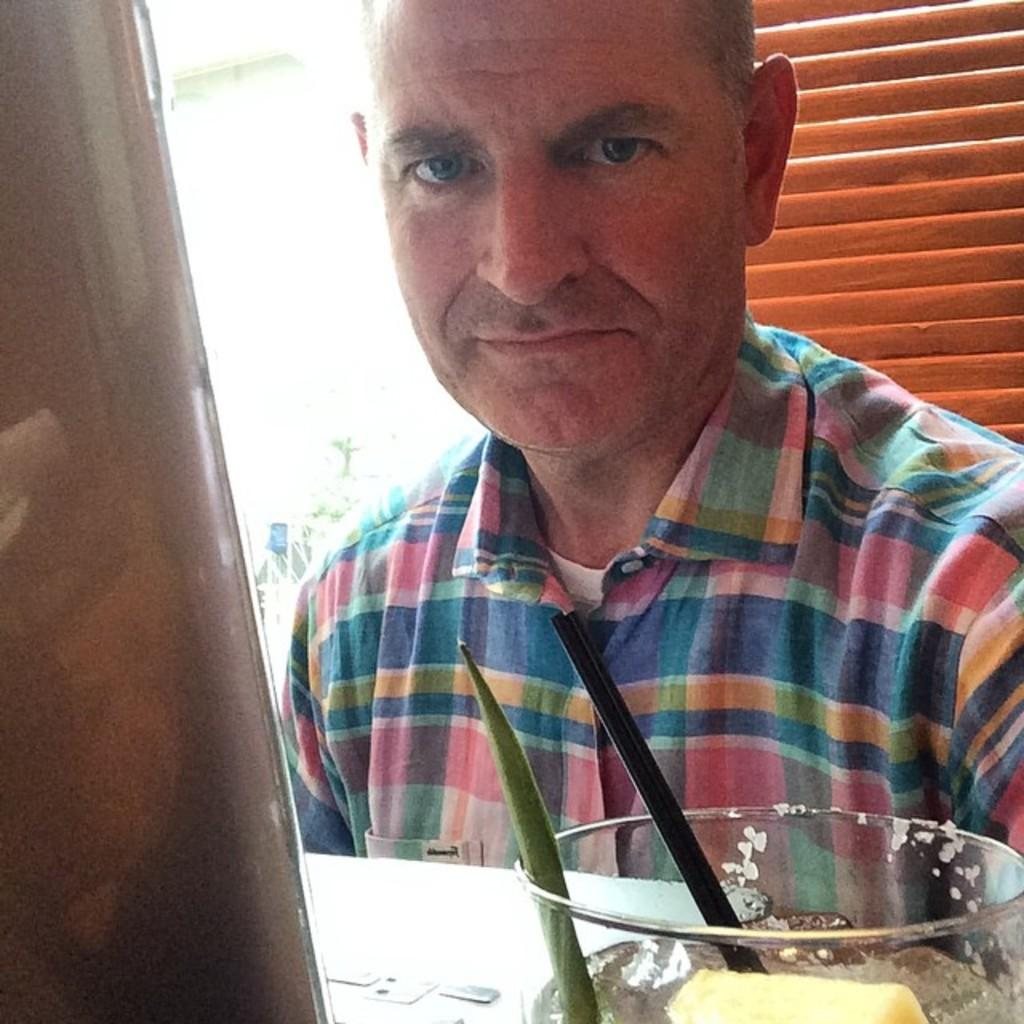What can be seen in the image? There is a person in the image. Can you describe the person's clothing? The person is wearing a blue and pink color shirt. What is in front of the person? There is a bowl in front of the person. What is visible in the background of the image? There is a window in the background of the image. What is the color of the window? The window is brown in color. Who is the owner of the bowl in the image? The facts provided do not mention the ownership of the bowl, so it cannot be determined from the image. Can you tell me how the person is answering the question in the image? There is no indication in the image that the person is answering a question, so it cannot be determined from the image. 